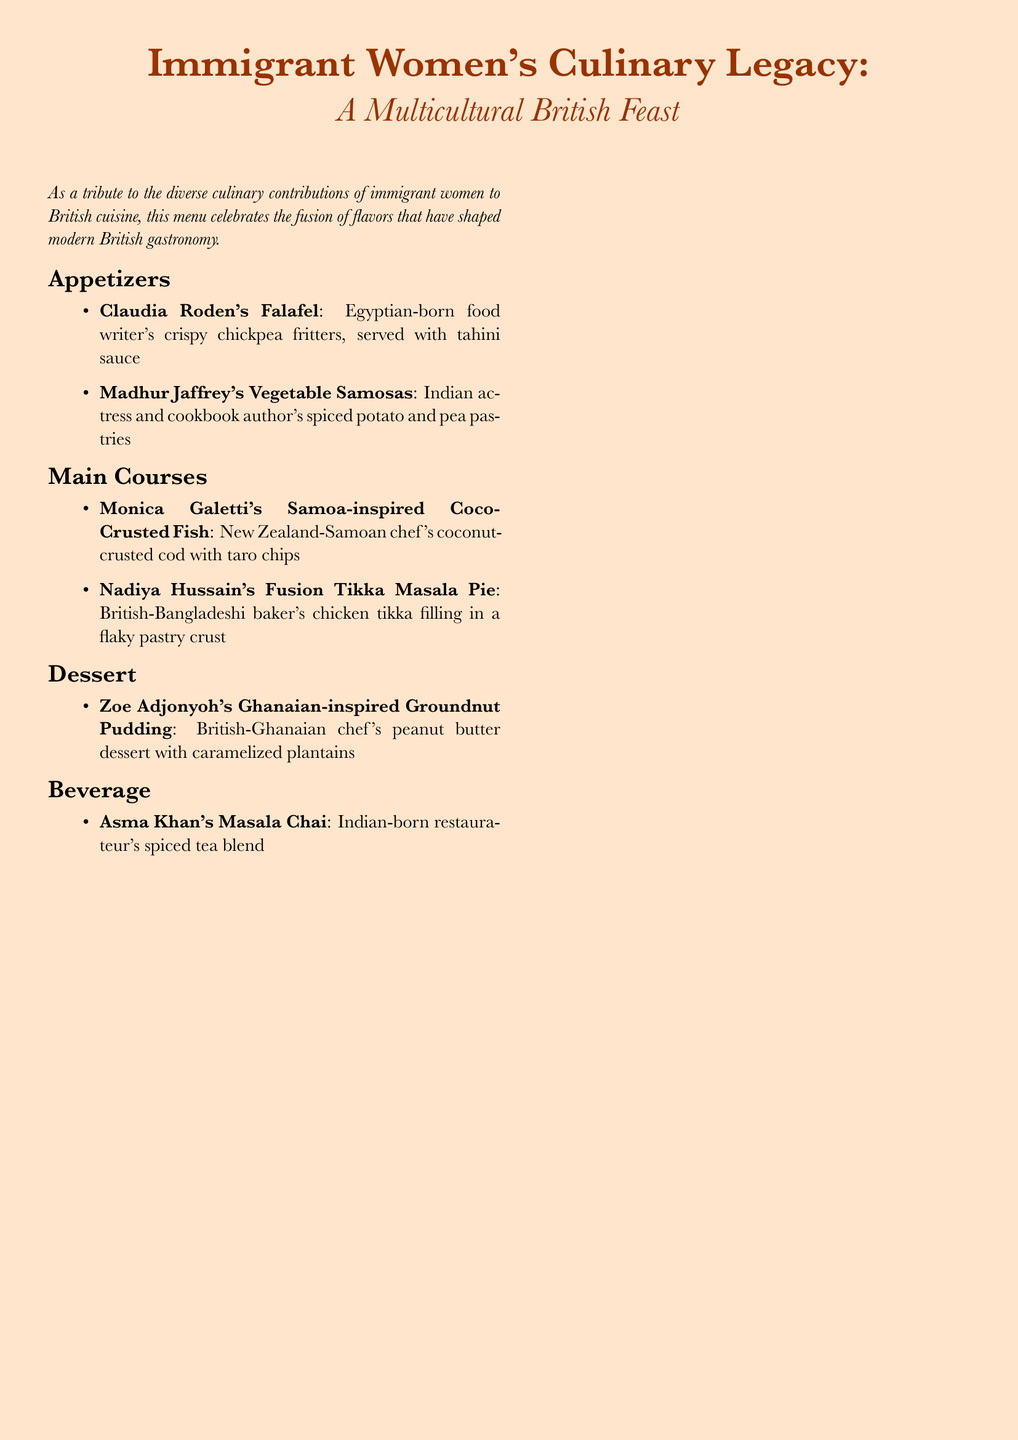What is the title of the menu? The title is prominently displayed at the top of the document, stating the theme and focus on immigrant women's culinary contributions.
Answer: Immigrant Women's Culinary Legacy: A Multicultural British Feast Who is the chef associated with the falafel dish? The document lists chefs with their respective dishes, specifically stating Claudia Roden for the falafel dish.
Answer: Claudia Roden What type of dessert is featured on the menu? The menu describes desserts in a specific section; the only dessert listed is groundnut pudding.
Answer: Groundnut Pudding How many main courses are included in the menu? By counting the items listed under the main course section, we find there are two dishes provided.
Answer: 2 Which beverage is offered on the menu? The beverage section includes only one item, explicitly named masala chai.
Answer: Masala Chai What is the main ingredient in the vegetable samosas? The document mentions the content of the vegetable samosas, including spiced potatoes and peas as the primary filling.
Answer: Potato and pea Which chef is known for a banana-related dessert? The menu references a specific dessert from Zoe Adjonyoh, which involves caramelized plantains, linking her to the banana-related dish.
Answer: Zoe Adjonyoh What cuisine is the Coco-Crusted Fish inspired by? The menu specifies the origin of the dish to be inspired by Samoan cuisine, highlighting its cultural influences.
Answer: Samoa Who contributed to the composition of this menu? The introductory statement in the document encompasses the contributions of immigrant women to British cuisine, forming the essence of the menu's celebration.
Answer: Immigrant women 